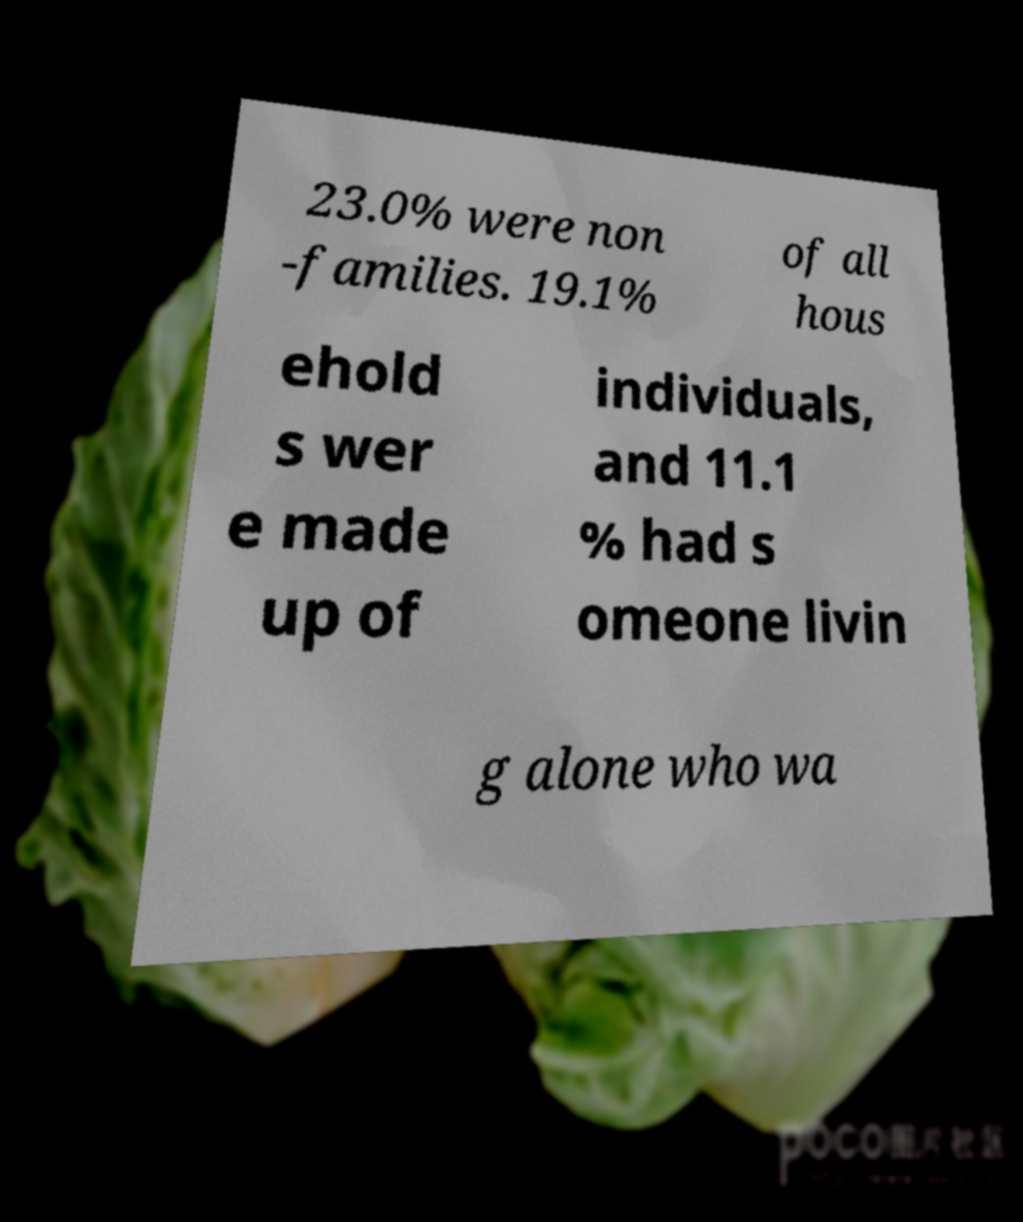Can you accurately transcribe the text from the provided image for me? 23.0% were non -families. 19.1% of all hous ehold s wer e made up of individuals, and 11.1 % had s omeone livin g alone who wa 